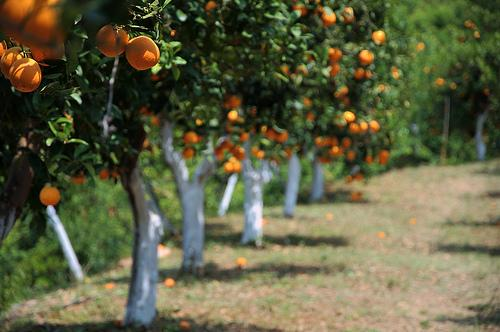Provide a clear and concise description of the image for a visual entailment task. The image contains tall orange trees with green leaves, white bark, oranges on both the ground and hanging from branches, and a white pipe in the ground. Which object has the largest image size, and what task can be based on this information? The largest image size belongs to the description "trees that have oranges". A referential expression grounding task can be based on this information. Identify the key elements in this image for a product advertisement promoting fresh oranges. A group of oranges on a tree, oranges on the ground, and several orange trees in the garden are key elements for a fresh oranges advertisement. Based on the textual information, what visual entailment task can be created from the given image? The task could be determining whether a statement like "Oranges are growing on tall trees" can be visually entailed from the image. Using the information provided, describe the appearance of the tree leaves and bark. The tree leaves are green and the tree bark is white. Identify an important feature of the oranges in the image and create a question for a multi-choice VQA task. d) Blue What is the most common location of oranges in the image? Mention a suitable task for this observation. The most common location of oranges in the image is on the trees. A multi choice VQA task would be suitable for this observation. Imagine a scene based on the given information, and describe an object you might find in that scene. In a scene with a grove of tall orange trees and oranges on the ground, I might also find a ladder used for picking oranges that are higher up. Count how many oranges are on the ground in the image and describe their surrounding. There are multiple oranges on the ground, with 4 distinct groups described, surrounded by dead grass and shadow of a tree. 